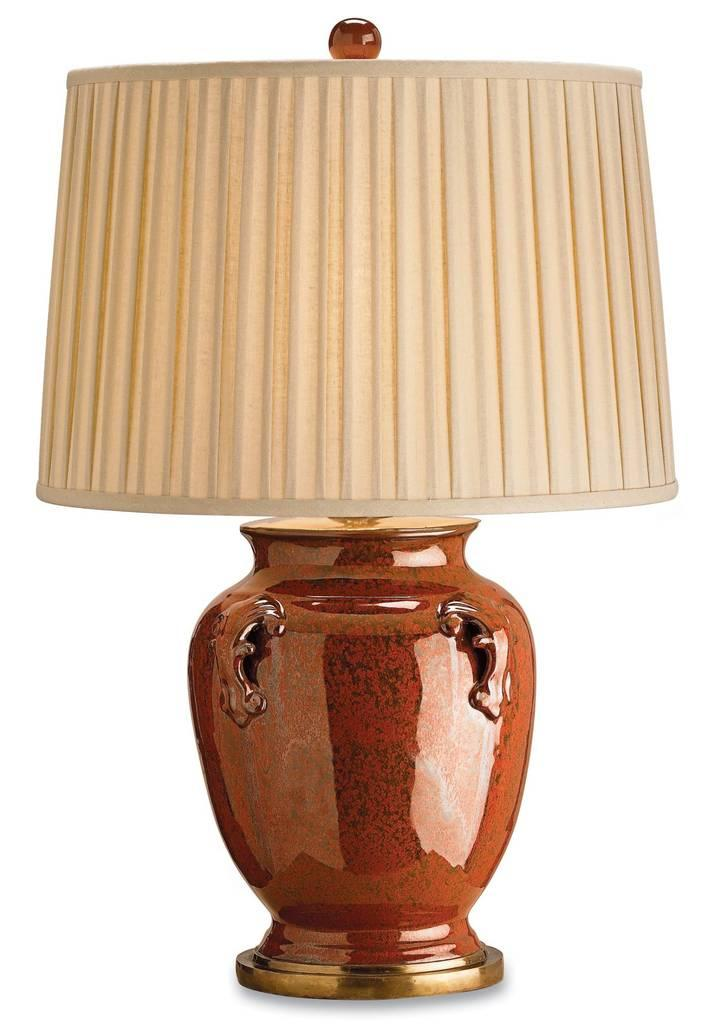What object can be seen in the image that provides light? There is a lamp in the image. What is the color of the lamp base? The lamp base is brown in color. What covers the light source of the lamp? There is a lamp shade in the image. How is the lamp shade connected to the lamp base? The lamp shade is attached to the lamp base. What color is the background of the image? The background of the image appears to be white. What type of creature is sitting on the quince in the image? There is no quince or creature present in the image. What is the title of the book on the table in the image? There is no book or table present in the image. 